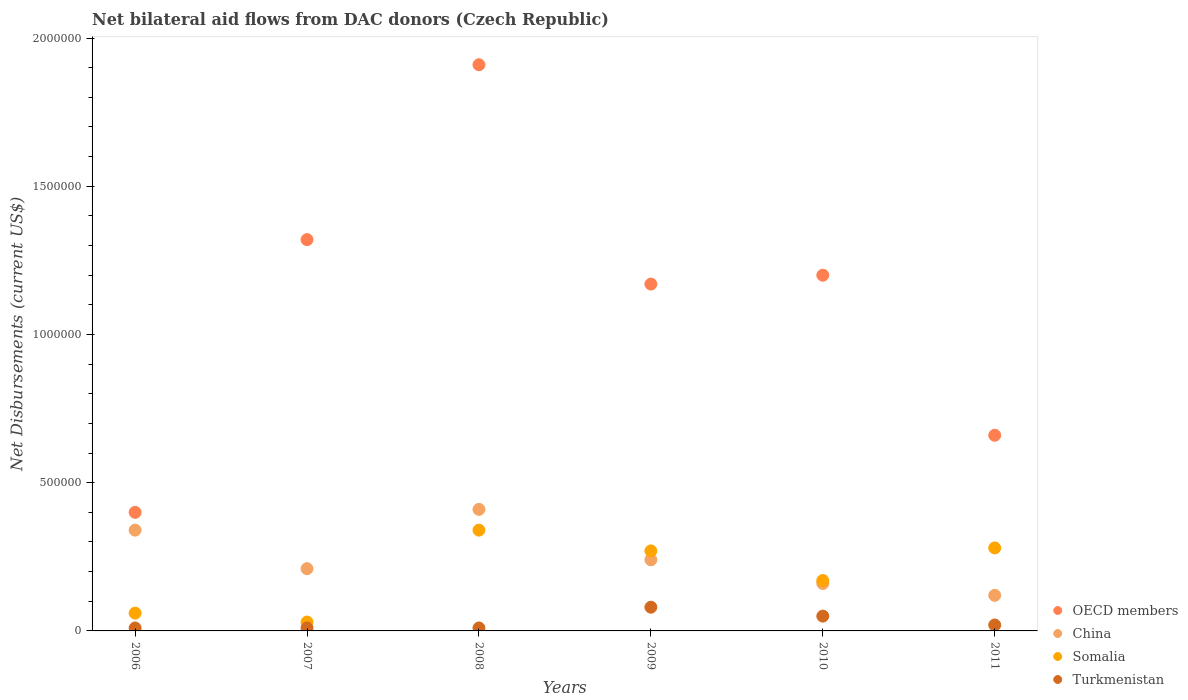How many different coloured dotlines are there?
Offer a very short reply. 4. What is the net bilateral aid flows in China in 2007?
Offer a very short reply. 2.10e+05. Across all years, what is the maximum net bilateral aid flows in China?
Your answer should be very brief. 4.10e+05. Across all years, what is the minimum net bilateral aid flows in Somalia?
Keep it short and to the point. 3.00e+04. In which year was the net bilateral aid flows in Somalia maximum?
Give a very brief answer. 2008. In which year was the net bilateral aid flows in China minimum?
Give a very brief answer. 2011. What is the total net bilateral aid flows in Somalia in the graph?
Keep it short and to the point. 1.15e+06. What is the difference between the net bilateral aid flows in China in 2006 and that in 2009?
Make the answer very short. 1.00e+05. What is the difference between the net bilateral aid flows in Somalia in 2006 and the net bilateral aid flows in China in 2007?
Ensure brevity in your answer.  -1.50e+05. What is the average net bilateral aid flows in Somalia per year?
Give a very brief answer. 1.92e+05. In how many years, is the net bilateral aid flows in Turkmenistan greater than 1000000 US$?
Provide a succinct answer. 0. What is the ratio of the net bilateral aid flows in China in 2008 to that in 2010?
Keep it short and to the point. 2.56. What is the difference between the highest and the lowest net bilateral aid flows in Somalia?
Provide a short and direct response. 3.10e+05. Is it the case that in every year, the sum of the net bilateral aid flows in Somalia and net bilateral aid flows in OECD members  is greater than the sum of net bilateral aid flows in China and net bilateral aid flows in Turkmenistan?
Provide a succinct answer. Yes. Does the net bilateral aid flows in China monotonically increase over the years?
Provide a succinct answer. No. Is the net bilateral aid flows in Somalia strictly less than the net bilateral aid flows in Turkmenistan over the years?
Ensure brevity in your answer.  No. How many dotlines are there?
Keep it short and to the point. 4. How many years are there in the graph?
Your answer should be very brief. 6. What is the difference between two consecutive major ticks on the Y-axis?
Make the answer very short. 5.00e+05. Does the graph contain any zero values?
Make the answer very short. No. Where does the legend appear in the graph?
Your answer should be very brief. Bottom right. How are the legend labels stacked?
Offer a very short reply. Vertical. What is the title of the graph?
Provide a succinct answer. Net bilateral aid flows from DAC donors (Czech Republic). Does "OECD members" appear as one of the legend labels in the graph?
Your response must be concise. Yes. What is the label or title of the Y-axis?
Your answer should be very brief. Net Disbursements (current US$). What is the Net Disbursements (current US$) in Turkmenistan in 2006?
Provide a short and direct response. 10000. What is the Net Disbursements (current US$) in OECD members in 2007?
Your answer should be very brief. 1.32e+06. What is the Net Disbursements (current US$) in China in 2007?
Ensure brevity in your answer.  2.10e+05. What is the Net Disbursements (current US$) of Turkmenistan in 2007?
Offer a very short reply. 10000. What is the Net Disbursements (current US$) of OECD members in 2008?
Keep it short and to the point. 1.91e+06. What is the Net Disbursements (current US$) of Somalia in 2008?
Your answer should be very brief. 3.40e+05. What is the Net Disbursements (current US$) in OECD members in 2009?
Make the answer very short. 1.17e+06. What is the Net Disbursements (current US$) in China in 2009?
Provide a short and direct response. 2.40e+05. What is the Net Disbursements (current US$) in Somalia in 2009?
Offer a terse response. 2.70e+05. What is the Net Disbursements (current US$) in Turkmenistan in 2009?
Ensure brevity in your answer.  8.00e+04. What is the Net Disbursements (current US$) in OECD members in 2010?
Ensure brevity in your answer.  1.20e+06. What is the Net Disbursements (current US$) in China in 2010?
Ensure brevity in your answer.  1.60e+05. What is the Net Disbursements (current US$) in Turkmenistan in 2010?
Make the answer very short. 5.00e+04. What is the Net Disbursements (current US$) in Somalia in 2011?
Provide a short and direct response. 2.80e+05. What is the Net Disbursements (current US$) of Turkmenistan in 2011?
Make the answer very short. 2.00e+04. Across all years, what is the maximum Net Disbursements (current US$) in OECD members?
Offer a very short reply. 1.91e+06. Across all years, what is the maximum Net Disbursements (current US$) in Somalia?
Provide a succinct answer. 3.40e+05. Across all years, what is the maximum Net Disbursements (current US$) of Turkmenistan?
Your answer should be very brief. 8.00e+04. Across all years, what is the minimum Net Disbursements (current US$) in OECD members?
Your answer should be very brief. 4.00e+05. Across all years, what is the minimum Net Disbursements (current US$) in Somalia?
Your answer should be compact. 3.00e+04. What is the total Net Disbursements (current US$) of OECD members in the graph?
Provide a succinct answer. 6.66e+06. What is the total Net Disbursements (current US$) of China in the graph?
Ensure brevity in your answer.  1.48e+06. What is the total Net Disbursements (current US$) of Somalia in the graph?
Your answer should be compact. 1.15e+06. What is the total Net Disbursements (current US$) of Turkmenistan in the graph?
Your response must be concise. 1.80e+05. What is the difference between the Net Disbursements (current US$) in OECD members in 2006 and that in 2007?
Your answer should be very brief. -9.20e+05. What is the difference between the Net Disbursements (current US$) of Turkmenistan in 2006 and that in 2007?
Your answer should be very brief. 0. What is the difference between the Net Disbursements (current US$) in OECD members in 2006 and that in 2008?
Provide a short and direct response. -1.51e+06. What is the difference between the Net Disbursements (current US$) in China in 2006 and that in 2008?
Your answer should be very brief. -7.00e+04. What is the difference between the Net Disbursements (current US$) in Somalia in 2006 and that in 2008?
Offer a terse response. -2.80e+05. What is the difference between the Net Disbursements (current US$) of OECD members in 2006 and that in 2009?
Make the answer very short. -7.70e+05. What is the difference between the Net Disbursements (current US$) in Somalia in 2006 and that in 2009?
Your response must be concise. -2.10e+05. What is the difference between the Net Disbursements (current US$) in Turkmenistan in 2006 and that in 2009?
Make the answer very short. -7.00e+04. What is the difference between the Net Disbursements (current US$) in OECD members in 2006 and that in 2010?
Ensure brevity in your answer.  -8.00e+05. What is the difference between the Net Disbursements (current US$) of Turkmenistan in 2006 and that in 2010?
Your answer should be compact. -4.00e+04. What is the difference between the Net Disbursements (current US$) in OECD members in 2006 and that in 2011?
Keep it short and to the point. -2.60e+05. What is the difference between the Net Disbursements (current US$) of China in 2006 and that in 2011?
Keep it short and to the point. 2.20e+05. What is the difference between the Net Disbursements (current US$) of Turkmenistan in 2006 and that in 2011?
Ensure brevity in your answer.  -10000. What is the difference between the Net Disbursements (current US$) of OECD members in 2007 and that in 2008?
Make the answer very short. -5.90e+05. What is the difference between the Net Disbursements (current US$) in Somalia in 2007 and that in 2008?
Give a very brief answer. -3.10e+05. What is the difference between the Net Disbursements (current US$) of Turkmenistan in 2007 and that in 2008?
Your response must be concise. 0. What is the difference between the Net Disbursements (current US$) in OECD members in 2007 and that in 2009?
Your answer should be compact. 1.50e+05. What is the difference between the Net Disbursements (current US$) of China in 2007 and that in 2009?
Your answer should be very brief. -3.00e+04. What is the difference between the Net Disbursements (current US$) in China in 2007 and that in 2010?
Provide a short and direct response. 5.00e+04. What is the difference between the Net Disbursements (current US$) in Turkmenistan in 2007 and that in 2010?
Keep it short and to the point. -4.00e+04. What is the difference between the Net Disbursements (current US$) of Somalia in 2007 and that in 2011?
Your answer should be very brief. -2.50e+05. What is the difference between the Net Disbursements (current US$) in Turkmenistan in 2007 and that in 2011?
Ensure brevity in your answer.  -10000. What is the difference between the Net Disbursements (current US$) of OECD members in 2008 and that in 2009?
Your answer should be very brief. 7.40e+05. What is the difference between the Net Disbursements (current US$) in China in 2008 and that in 2009?
Provide a short and direct response. 1.70e+05. What is the difference between the Net Disbursements (current US$) of Somalia in 2008 and that in 2009?
Offer a very short reply. 7.00e+04. What is the difference between the Net Disbursements (current US$) in OECD members in 2008 and that in 2010?
Provide a succinct answer. 7.10e+05. What is the difference between the Net Disbursements (current US$) in China in 2008 and that in 2010?
Your answer should be very brief. 2.50e+05. What is the difference between the Net Disbursements (current US$) of Somalia in 2008 and that in 2010?
Ensure brevity in your answer.  1.70e+05. What is the difference between the Net Disbursements (current US$) of Turkmenistan in 2008 and that in 2010?
Your answer should be very brief. -4.00e+04. What is the difference between the Net Disbursements (current US$) in OECD members in 2008 and that in 2011?
Ensure brevity in your answer.  1.25e+06. What is the difference between the Net Disbursements (current US$) of Somalia in 2008 and that in 2011?
Ensure brevity in your answer.  6.00e+04. What is the difference between the Net Disbursements (current US$) of OECD members in 2009 and that in 2010?
Ensure brevity in your answer.  -3.00e+04. What is the difference between the Net Disbursements (current US$) of Turkmenistan in 2009 and that in 2010?
Your answer should be very brief. 3.00e+04. What is the difference between the Net Disbursements (current US$) in OECD members in 2009 and that in 2011?
Provide a short and direct response. 5.10e+05. What is the difference between the Net Disbursements (current US$) in China in 2009 and that in 2011?
Provide a short and direct response. 1.20e+05. What is the difference between the Net Disbursements (current US$) of Somalia in 2009 and that in 2011?
Offer a terse response. -10000. What is the difference between the Net Disbursements (current US$) in Turkmenistan in 2009 and that in 2011?
Make the answer very short. 6.00e+04. What is the difference between the Net Disbursements (current US$) of OECD members in 2010 and that in 2011?
Offer a terse response. 5.40e+05. What is the difference between the Net Disbursements (current US$) of Somalia in 2010 and that in 2011?
Offer a terse response. -1.10e+05. What is the difference between the Net Disbursements (current US$) in Turkmenistan in 2010 and that in 2011?
Offer a very short reply. 3.00e+04. What is the difference between the Net Disbursements (current US$) of OECD members in 2006 and the Net Disbursements (current US$) of Turkmenistan in 2007?
Offer a terse response. 3.90e+05. What is the difference between the Net Disbursements (current US$) of China in 2006 and the Net Disbursements (current US$) of Somalia in 2007?
Give a very brief answer. 3.10e+05. What is the difference between the Net Disbursements (current US$) in OECD members in 2006 and the Net Disbursements (current US$) in China in 2009?
Make the answer very short. 1.60e+05. What is the difference between the Net Disbursements (current US$) of OECD members in 2006 and the Net Disbursements (current US$) of Somalia in 2009?
Offer a very short reply. 1.30e+05. What is the difference between the Net Disbursements (current US$) in OECD members in 2006 and the Net Disbursements (current US$) in Turkmenistan in 2009?
Keep it short and to the point. 3.20e+05. What is the difference between the Net Disbursements (current US$) in China in 2006 and the Net Disbursements (current US$) in Somalia in 2009?
Give a very brief answer. 7.00e+04. What is the difference between the Net Disbursements (current US$) of OECD members in 2006 and the Net Disbursements (current US$) of China in 2010?
Keep it short and to the point. 2.40e+05. What is the difference between the Net Disbursements (current US$) of OECD members in 2006 and the Net Disbursements (current US$) of Somalia in 2010?
Your answer should be compact. 2.30e+05. What is the difference between the Net Disbursements (current US$) in China in 2006 and the Net Disbursements (current US$) in Somalia in 2010?
Your response must be concise. 1.70e+05. What is the difference between the Net Disbursements (current US$) of China in 2006 and the Net Disbursements (current US$) of Turkmenistan in 2010?
Your answer should be compact. 2.90e+05. What is the difference between the Net Disbursements (current US$) in OECD members in 2007 and the Net Disbursements (current US$) in China in 2008?
Your answer should be very brief. 9.10e+05. What is the difference between the Net Disbursements (current US$) in OECD members in 2007 and the Net Disbursements (current US$) in Somalia in 2008?
Your response must be concise. 9.80e+05. What is the difference between the Net Disbursements (current US$) of OECD members in 2007 and the Net Disbursements (current US$) of Turkmenistan in 2008?
Make the answer very short. 1.31e+06. What is the difference between the Net Disbursements (current US$) in China in 2007 and the Net Disbursements (current US$) in Turkmenistan in 2008?
Your answer should be very brief. 2.00e+05. What is the difference between the Net Disbursements (current US$) in OECD members in 2007 and the Net Disbursements (current US$) in China in 2009?
Your answer should be compact. 1.08e+06. What is the difference between the Net Disbursements (current US$) of OECD members in 2007 and the Net Disbursements (current US$) of Somalia in 2009?
Offer a very short reply. 1.05e+06. What is the difference between the Net Disbursements (current US$) of OECD members in 2007 and the Net Disbursements (current US$) of Turkmenistan in 2009?
Offer a terse response. 1.24e+06. What is the difference between the Net Disbursements (current US$) in China in 2007 and the Net Disbursements (current US$) in Turkmenistan in 2009?
Your response must be concise. 1.30e+05. What is the difference between the Net Disbursements (current US$) in Somalia in 2007 and the Net Disbursements (current US$) in Turkmenistan in 2009?
Your answer should be very brief. -5.00e+04. What is the difference between the Net Disbursements (current US$) of OECD members in 2007 and the Net Disbursements (current US$) of China in 2010?
Your response must be concise. 1.16e+06. What is the difference between the Net Disbursements (current US$) in OECD members in 2007 and the Net Disbursements (current US$) in Somalia in 2010?
Offer a very short reply. 1.15e+06. What is the difference between the Net Disbursements (current US$) of OECD members in 2007 and the Net Disbursements (current US$) of Turkmenistan in 2010?
Your answer should be compact. 1.27e+06. What is the difference between the Net Disbursements (current US$) in China in 2007 and the Net Disbursements (current US$) in Somalia in 2010?
Ensure brevity in your answer.  4.00e+04. What is the difference between the Net Disbursements (current US$) of China in 2007 and the Net Disbursements (current US$) of Turkmenistan in 2010?
Your answer should be compact. 1.60e+05. What is the difference between the Net Disbursements (current US$) in OECD members in 2007 and the Net Disbursements (current US$) in China in 2011?
Offer a terse response. 1.20e+06. What is the difference between the Net Disbursements (current US$) of OECD members in 2007 and the Net Disbursements (current US$) of Somalia in 2011?
Your answer should be compact. 1.04e+06. What is the difference between the Net Disbursements (current US$) in OECD members in 2007 and the Net Disbursements (current US$) in Turkmenistan in 2011?
Offer a terse response. 1.30e+06. What is the difference between the Net Disbursements (current US$) of China in 2007 and the Net Disbursements (current US$) of Turkmenistan in 2011?
Your answer should be compact. 1.90e+05. What is the difference between the Net Disbursements (current US$) in Somalia in 2007 and the Net Disbursements (current US$) in Turkmenistan in 2011?
Give a very brief answer. 10000. What is the difference between the Net Disbursements (current US$) in OECD members in 2008 and the Net Disbursements (current US$) in China in 2009?
Your answer should be very brief. 1.67e+06. What is the difference between the Net Disbursements (current US$) of OECD members in 2008 and the Net Disbursements (current US$) of Somalia in 2009?
Give a very brief answer. 1.64e+06. What is the difference between the Net Disbursements (current US$) of OECD members in 2008 and the Net Disbursements (current US$) of Turkmenistan in 2009?
Ensure brevity in your answer.  1.83e+06. What is the difference between the Net Disbursements (current US$) of China in 2008 and the Net Disbursements (current US$) of Turkmenistan in 2009?
Your answer should be very brief. 3.30e+05. What is the difference between the Net Disbursements (current US$) in Somalia in 2008 and the Net Disbursements (current US$) in Turkmenistan in 2009?
Offer a terse response. 2.60e+05. What is the difference between the Net Disbursements (current US$) in OECD members in 2008 and the Net Disbursements (current US$) in China in 2010?
Provide a succinct answer. 1.75e+06. What is the difference between the Net Disbursements (current US$) in OECD members in 2008 and the Net Disbursements (current US$) in Somalia in 2010?
Give a very brief answer. 1.74e+06. What is the difference between the Net Disbursements (current US$) of OECD members in 2008 and the Net Disbursements (current US$) of Turkmenistan in 2010?
Your answer should be compact. 1.86e+06. What is the difference between the Net Disbursements (current US$) in China in 2008 and the Net Disbursements (current US$) in Somalia in 2010?
Ensure brevity in your answer.  2.40e+05. What is the difference between the Net Disbursements (current US$) in Somalia in 2008 and the Net Disbursements (current US$) in Turkmenistan in 2010?
Keep it short and to the point. 2.90e+05. What is the difference between the Net Disbursements (current US$) of OECD members in 2008 and the Net Disbursements (current US$) of China in 2011?
Provide a short and direct response. 1.79e+06. What is the difference between the Net Disbursements (current US$) of OECD members in 2008 and the Net Disbursements (current US$) of Somalia in 2011?
Offer a terse response. 1.63e+06. What is the difference between the Net Disbursements (current US$) of OECD members in 2008 and the Net Disbursements (current US$) of Turkmenistan in 2011?
Make the answer very short. 1.89e+06. What is the difference between the Net Disbursements (current US$) of OECD members in 2009 and the Net Disbursements (current US$) of China in 2010?
Your answer should be very brief. 1.01e+06. What is the difference between the Net Disbursements (current US$) in OECD members in 2009 and the Net Disbursements (current US$) in Somalia in 2010?
Offer a very short reply. 1.00e+06. What is the difference between the Net Disbursements (current US$) in OECD members in 2009 and the Net Disbursements (current US$) in Turkmenistan in 2010?
Your response must be concise. 1.12e+06. What is the difference between the Net Disbursements (current US$) in OECD members in 2009 and the Net Disbursements (current US$) in China in 2011?
Make the answer very short. 1.05e+06. What is the difference between the Net Disbursements (current US$) of OECD members in 2009 and the Net Disbursements (current US$) of Somalia in 2011?
Give a very brief answer. 8.90e+05. What is the difference between the Net Disbursements (current US$) of OECD members in 2009 and the Net Disbursements (current US$) of Turkmenistan in 2011?
Make the answer very short. 1.15e+06. What is the difference between the Net Disbursements (current US$) in Somalia in 2009 and the Net Disbursements (current US$) in Turkmenistan in 2011?
Provide a short and direct response. 2.50e+05. What is the difference between the Net Disbursements (current US$) in OECD members in 2010 and the Net Disbursements (current US$) in China in 2011?
Ensure brevity in your answer.  1.08e+06. What is the difference between the Net Disbursements (current US$) of OECD members in 2010 and the Net Disbursements (current US$) of Somalia in 2011?
Your answer should be compact. 9.20e+05. What is the difference between the Net Disbursements (current US$) of OECD members in 2010 and the Net Disbursements (current US$) of Turkmenistan in 2011?
Provide a short and direct response. 1.18e+06. What is the average Net Disbursements (current US$) in OECD members per year?
Your answer should be compact. 1.11e+06. What is the average Net Disbursements (current US$) of China per year?
Your response must be concise. 2.47e+05. What is the average Net Disbursements (current US$) in Somalia per year?
Provide a short and direct response. 1.92e+05. In the year 2006, what is the difference between the Net Disbursements (current US$) in OECD members and Net Disbursements (current US$) in Turkmenistan?
Make the answer very short. 3.90e+05. In the year 2006, what is the difference between the Net Disbursements (current US$) of China and Net Disbursements (current US$) of Somalia?
Ensure brevity in your answer.  2.80e+05. In the year 2007, what is the difference between the Net Disbursements (current US$) in OECD members and Net Disbursements (current US$) in China?
Offer a terse response. 1.11e+06. In the year 2007, what is the difference between the Net Disbursements (current US$) in OECD members and Net Disbursements (current US$) in Somalia?
Give a very brief answer. 1.29e+06. In the year 2007, what is the difference between the Net Disbursements (current US$) of OECD members and Net Disbursements (current US$) of Turkmenistan?
Your answer should be compact. 1.31e+06. In the year 2007, what is the difference between the Net Disbursements (current US$) in China and Net Disbursements (current US$) in Somalia?
Your answer should be compact. 1.80e+05. In the year 2007, what is the difference between the Net Disbursements (current US$) in China and Net Disbursements (current US$) in Turkmenistan?
Provide a succinct answer. 2.00e+05. In the year 2007, what is the difference between the Net Disbursements (current US$) of Somalia and Net Disbursements (current US$) of Turkmenistan?
Your answer should be compact. 2.00e+04. In the year 2008, what is the difference between the Net Disbursements (current US$) of OECD members and Net Disbursements (current US$) of China?
Provide a short and direct response. 1.50e+06. In the year 2008, what is the difference between the Net Disbursements (current US$) of OECD members and Net Disbursements (current US$) of Somalia?
Provide a succinct answer. 1.57e+06. In the year 2008, what is the difference between the Net Disbursements (current US$) of OECD members and Net Disbursements (current US$) of Turkmenistan?
Your answer should be very brief. 1.90e+06. In the year 2008, what is the difference between the Net Disbursements (current US$) of China and Net Disbursements (current US$) of Somalia?
Your answer should be very brief. 7.00e+04. In the year 2008, what is the difference between the Net Disbursements (current US$) in China and Net Disbursements (current US$) in Turkmenistan?
Your answer should be compact. 4.00e+05. In the year 2008, what is the difference between the Net Disbursements (current US$) in Somalia and Net Disbursements (current US$) in Turkmenistan?
Ensure brevity in your answer.  3.30e+05. In the year 2009, what is the difference between the Net Disbursements (current US$) in OECD members and Net Disbursements (current US$) in China?
Provide a succinct answer. 9.30e+05. In the year 2009, what is the difference between the Net Disbursements (current US$) of OECD members and Net Disbursements (current US$) of Turkmenistan?
Give a very brief answer. 1.09e+06. In the year 2009, what is the difference between the Net Disbursements (current US$) of China and Net Disbursements (current US$) of Somalia?
Give a very brief answer. -3.00e+04. In the year 2010, what is the difference between the Net Disbursements (current US$) in OECD members and Net Disbursements (current US$) in China?
Provide a short and direct response. 1.04e+06. In the year 2010, what is the difference between the Net Disbursements (current US$) in OECD members and Net Disbursements (current US$) in Somalia?
Make the answer very short. 1.03e+06. In the year 2010, what is the difference between the Net Disbursements (current US$) in OECD members and Net Disbursements (current US$) in Turkmenistan?
Keep it short and to the point. 1.15e+06. In the year 2010, what is the difference between the Net Disbursements (current US$) of Somalia and Net Disbursements (current US$) of Turkmenistan?
Your response must be concise. 1.20e+05. In the year 2011, what is the difference between the Net Disbursements (current US$) of OECD members and Net Disbursements (current US$) of China?
Ensure brevity in your answer.  5.40e+05. In the year 2011, what is the difference between the Net Disbursements (current US$) in OECD members and Net Disbursements (current US$) in Turkmenistan?
Your answer should be very brief. 6.40e+05. In the year 2011, what is the difference between the Net Disbursements (current US$) in China and Net Disbursements (current US$) in Somalia?
Make the answer very short. -1.60e+05. What is the ratio of the Net Disbursements (current US$) in OECD members in 2006 to that in 2007?
Keep it short and to the point. 0.3. What is the ratio of the Net Disbursements (current US$) of China in 2006 to that in 2007?
Keep it short and to the point. 1.62. What is the ratio of the Net Disbursements (current US$) in Somalia in 2006 to that in 2007?
Your answer should be very brief. 2. What is the ratio of the Net Disbursements (current US$) of OECD members in 2006 to that in 2008?
Your answer should be very brief. 0.21. What is the ratio of the Net Disbursements (current US$) in China in 2006 to that in 2008?
Offer a very short reply. 0.83. What is the ratio of the Net Disbursements (current US$) of Somalia in 2006 to that in 2008?
Make the answer very short. 0.18. What is the ratio of the Net Disbursements (current US$) of Turkmenistan in 2006 to that in 2008?
Provide a short and direct response. 1. What is the ratio of the Net Disbursements (current US$) of OECD members in 2006 to that in 2009?
Ensure brevity in your answer.  0.34. What is the ratio of the Net Disbursements (current US$) in China in 2006 to that in 2009?
Ensure brevity in your answer.  1.42. What is the ratio of the Net Disbursements (current US$) of Somalia in 2006 to that in 2009?
Make the answer very short. 0.22. What is the ratio of the Net Disbursements (current US$) in Turkmenistan in 2006 to that in 2009?
Give a very brief answer. 0.12. What is the ratio of the Net Disbursements (current US$) of OECD members in 2006 to that in 2010?
Provide a short and direct response. 0.33. What is the ratio of the Net Disbursements (current US$) of China in 2006 to that in 2010?
Offer a very short reply. 2.12. What is the ratio of the Net Disbursements (current US$) of Somalia in 2006 to that in 2010?
Offer a terse response. 0.35. What is the ratio of the Net Disbursements (current US$) in OECD members in 2006 to that in 2011?
Your answer should be very brief. 0.61. What is the ratio of the Net Disbursements (current US$) in China in 2006 to that in 2011?
Ensure brevity in your answer.  2.83. What is the ratio of the Net Disbursements (current US$) of Somalia in 2006 to that in 2011?
Offer a terse response. 0.21. What is the ratio of the Net Disbursements (current US$) of OECD members in 2007 to that in 2008?
Your answer should be compact. 0.69. What is the ratio of the Net Disbursements (current US$) in China in 2007 to that in 2008?
Offer a terse response. 0.51. What is the ratio of the Net Disbursements (current US$) of Somalia in 2007 to that in 2008?
Give a very brief answer. 0.09. What is the ratio of the Net Disbursements (current US$) in OECD members in 2007 to that in 2009?
Your response must be concise. 1.13. What is the ratio of the Net Disbursements (current US$) of Somalia in 2007 to that in 2009?
Offer a terse response. 0.11. What is the ratio of the Net Disbursements (current US$) in OECD members in 2007 to that in 2010?
Keep it short and to the point. 1.1. What is the ratio of the Net Disbursements (current US$) in China in 2007 to that in 2010?
Give a very brief answer. 1.31. What is the ratio of the Net Disbursements (current US$) of Somalia in 2007 to that in 2010?
Your answer should be compact. 0.18. What is the ratio of the Net Disbursements (current US$) of Turkmenistan in 2007 to that in 2010?
Keep it short and to the point. 0.2. What is the ratio of the Net Disbursements (current US$) in China in 2007 to that in 2011?
Offer a very short reply. 1.75. What is the ratio of the Net Disbursements (current US$) of Somalia in 2007 to that in 2011?
Offer a very short reply. 0.11. What is the ratio of the Net Disbursements (current US$) in OECD members in 2008 to that in 2009?
Provide a short and direct response. 1.63. What is the ratio of the Net Disbursements (current US$) in China in 2008 to that in 2009?
Offer a very short reply. 1.71. What is the ratio of the Net Disbursements (current US$) in Somalia in 2008 to that in 2009?
Your answer should be very brief. 1.26. What is the ratio of the Net Disbursements (current US$) of OECD members in 2008 to that in 2010?
Your answer should be compact. 1.59. What is the ratio of the Net Disbursements (current US$) in China in 2008 to that in 2010?
Make the answer very short. 2.56. What is the ratio of the Net Disbursements (current US$) of Somalia in 2008 to that in 2010?
Offer a terse response. 2. What is the ratio of the Net Disbursements (current US$) in OECD members in 2008 to that in 2011?
Your answer should be very brief. 2.89. What is the ratio of the Net Disbursements (current US$) of China in 2008 to that in 2011?
Provide a short and direct response. 3.42. What is the ratio of the Net Disbursements (current US$) of Somalia in 2008 to that in 2011?
Provide a succinct answer. 1.21. What is the ratio of the Net Disbursements (current US$) of Turkmenistan in 2008 to that in 2011?
Make the answer very short. 0.5. What is the ratio of the Net Disbursements (current US$) in OECD members in 2009 to that in 2010?
Provide a succinct answer. 0.97. What is the ratio of the Net Disbursements (current US$) of Somalia in 2009 to that in 2010?
Ensure brevity in your answer.  1.59. What is the ratio of the Net Disbursements (current US$) in Turkmenistan in 2009 to that in 2010?
Keep it short and to the point. 1.6. What is the ratio of the Net Disbursements (current US$) in OECD members in 2009 to that in 2011?
Your answer should be compact. 1.77. What is the ratio of the Net Disbursements (current US$) in Turkmenistan in 2009 to that in 2011?
Provide a succinct answer. 4. What is the ratio of the Net Disbursements (current US$) of OECD members in 2010 to that in 2011?
Your answer should be compact. 1.82. What is the ratio of the Net Disbursements (current US$) of China in 2010 to that in 2011?
Your answer should be very brief. 1.33. What is the ratio of the Net Disbursements (current US$) of Somalia in 2010 to that in 2011?
Keep it short and to the point. 0.61. What is the difference between the highest and the second highest Net Disbursements (current US$) in OECD members?
Your answer should be very brief. 5.90e+05. What is the difference between the highest and the second highest Net Disbursements (current US$) of China?
Give a very brief answer. 7.00e+04. What is the difference between the highest and the second highest Net Disbursements (current US$) of Somalia?
Your answer should be compact. 6.00e+04. What is the difference between the highest and the lowest Net Disbursements (current US$) in OECD members?
Your response must be concise. 1.51e+06. What is the difference between the highest and the lowest Net Disbursements (current US$) in China?
Keep it short and to the point. 2.90e+05. 